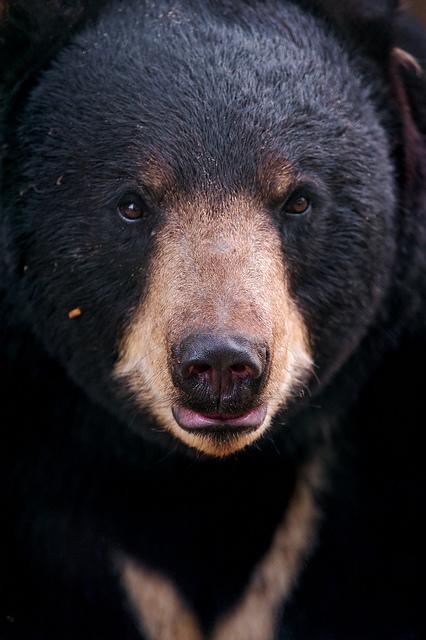What color are the animal's eyes?
Quick response, please. Brown. What color is the bears snout?
Be succinct. Brown. Is there a tree in the image?
Give a very brief answer. No. Is the bear angry?
Answer briefly. No. What color is the bear?
Give a very brief answer. Black. What animal is this?
Quick response, please. Bear. 